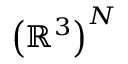<formula> <loc_0><loc_0><loc_500><loc_500>\left ( \mathbb { R } ^ { 3 } \right ) ^ { N }</formula> 